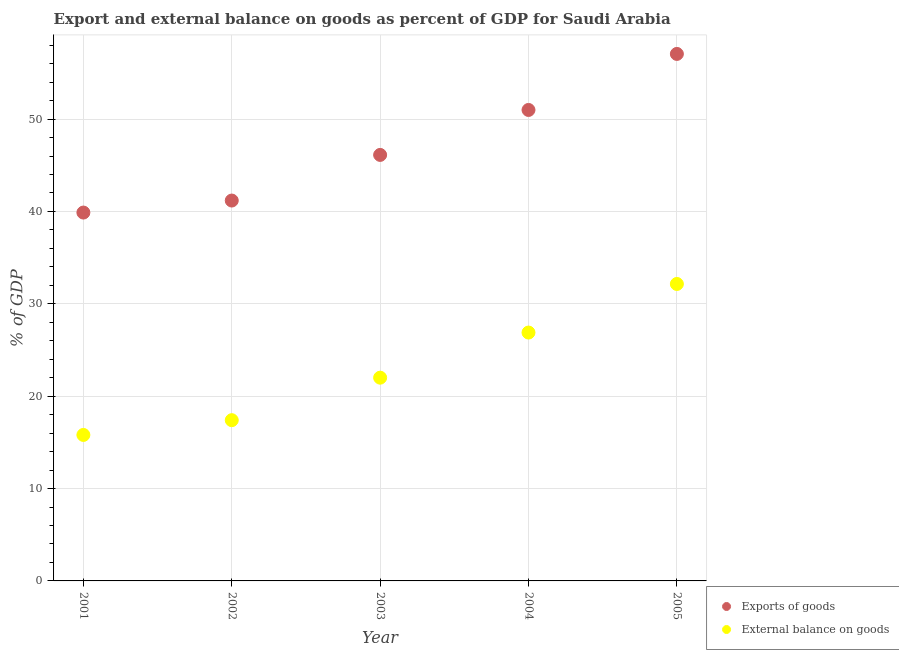How many different coloured dotlines are there?
Give a very brief answer. 2. What is the external balance on goods as percentage of gdp in 2005?
Provide a succinct answer. 32.15. Across all years, what is the maximum external balance on goods as percentage of gdp?
Keep it short and to the point. 32.15. Across all years, what is the minimum export of goods as percentage of gdp?
Provide a succinct answer. 39.88. In which year was the external balance on goods as percentage of gdp maximum?
Your answer should be compact. 2005. What is the total external balance on goods as percentage of gdp in the graph?
Your answer should be very brief. 114.24. What is the difference between the export of goods as percentage of gdp in 2003 and that in 2004?
Offer a terse response. -4.87. What is the difference between the export of goods as percentage of gdp in 2001 and the external balance on goods as percentage of gdp in 2002?
Your answer should be compact. 22.48. What is the average export of goods as percentage of gdp per year?
Make the answer very short. 47.04. In the year 2002, what is the difference between the export of goods as percentage of gdp and external balance on goods as percentage of gdp?
Your answer should be very brief. 23.78. What is the ratio of the export of goods as percentage of gdp in 2001 to that in 2003?
Give a very brief answer. 0.86. Is the external balance on goods as percentage of gdp in 2002 less than that in 2003?
Give a very brief answer. Yes. What is the difference between the highest and the second highest export of goods as percentage of gdp?
Your answer should be compact. 6.07. What is the difference between the highest and the lowest export of goods as percentage of gdp?
Ensure brevity in your answer.  17.17. How many dotlines are there?
Provide a succinct answer. 2. How many years are there in the graph?
Your answer should be compact. 5. What is the difference between two consecutive major ticks on the Y-axis?
Make the answer very short. 10. Are the values on the major ticks of Y-axis written in scientific E-notation?
Offer a terse response. No. Does the graph contain grids?
Offer a very short reply. Yes. Where does the legend appear in the graph?
Your answer should be very brief. Bottom right. How many legend labels are there?
Make the answer very short. 2. What is the title of the graph?
Your answer should be very brief. Export and external balance on goods as percent of GDP for Saudi Arabia. Does "Investment in Transport" appear as one of the legend labels in the graph?
Ensure brevity in your answer.  No. What is the label or title of the X-axis?
Give a very brief answer. Year. What is the label or title of the Y-axis?
Ensure brevity in your answer.  % of GDP. What is the % of GDP of Exports of goods in 2001?
Provide a succinct answer. 39.88. What is the % of GDP of External balance on goods in 2001?
Provide a short and direct response. 15.8. What is the % of GDP in Exports of goods in 2002?
Provide a short and direct response. 41.18. What is the % of GDP in External balance on goods in 2002?
Provide a succinct answer. 17.4. What is the % of GDP in Exports of goods in 2003?
Make the answer very short. 46.12. What is the % of GDP of External balance on goods in 2003?
Offer a terse response. 22. What is the % of GDP in Exports of goods in 2004?
Your answer should be compact. 50.99. What is the % of GDP in External balance on goods in 2004?
Keep it short and to the point. 26.89. What is the % of GDP of Exports of goods in 2005?
Ensure brevity in your answer.  57.05. What is the % of GDP of External balance on goods in 2005?
Your response must be concise. 32.15. Across all years, what is the maximum % of GDP of Exports of goods?
Offer a very short reply. 57.05. Across all years, what is the maximum % of GDP in External balance on goods?
Make the answer very short. 32.15. Across all years, what is the minimum % of GDP in Exports of goods?
Offer a terse response. 39.88. Across all years, what is the minimum % of GDP in External balance on goods?
Make the answer very short. 15.8. What is the total % of GDP in Exports of goods in the graph?
Offer a very short reply. 235.21. What is the total % of GDP of External balance on goods in the graph?
Offer a terse response. 114.24. What is the difference between the % of GDP of Exports of goods in 2001 and that in 2002?
Give a very brief answer. -1.3. What is the difference between the % of GDP in External balance on goods in 2001 and that in 2002?
Ensure brevity in your answer.  -1.6. What is the difference between the % of GDP of Exports of goods in 2001 and that in 2003?
Offer a very short reply. -6.24. What is the difference between the % of GDP of External balance on goods in 2001 and that in 2003?
Your answer should be very brief. -6.2. What is the difference between the % of GDP of Exports of goods in 2001 and that in 2004?
Give a very brief answer. -11.11. What is the difference between the % of GDP in External balance on goods in 2001 and that in 2004?
Give a very brief answer. -11.08. What is the difference between the % of GDP of Exports of goods in 2001 and that in 2005?
Ensure brevity in your answer.  -17.17. What is the difference between the % of GDP of External balance on goods in 2001 and that in 2005?
Give a very brief answer. -16.34. What is the difference between the % of GDP in Exports of goods in 2002 and that in 2003?
Provide a short and direct response. -4.94. What is the difference between the % of GDP of External balance on goods in 2002 and that in 2003?
Provide a succinct answer. -4.6. What is the difference between the % of GDP in Exports of goods in 2002 and that in 2004?
Give a very brief answer. -9.81. What is the difference between the % of GDP in External balance on goods in 2002 and that in 2004?
Ensure brevity in your answer.  -9.49. What is the difference between the % of GDP of Exports of goods in 2002 and that in 2005?
Provide a succinct answer. -15.87. What is the difference between the % of GDP of External balance on goods in 2002 and that in 2005?
Your answer should be compact. -14.75. What is the difference between the % of GDP of Exports of goods in 2003 and that in 2004?
Keep it short and to the point. -4.87. What is the difference between the % of GDP in External balance on goods in 2003 and that in 2004?
Give a very brief answer. -4.88. What is the difference between the % of GDP of Exports of goods in 2003 and that in 2005?
Provide a short and direct response. -10.93. What is the difference between the % of GDP of External balance on goods in 2003 and that in 2005?
Offer a very short reply. -10.14. What is the difference between the % of GDP of Exports of goods in 2004 and that in 2005?
Ensure brevity in your answer.  -6.07. What is the difference between the % of GDP of External balance on goods in 2004 and that in 2005?
Your answer should be very brief. -5.26. What is the difference between the % of GDP of Exports of goods in 2001 and the % of GDP of External balance on goods in 2002?
Provide a succinct answer. 22.48. What is the difference between the % of GDP of Exports of goods in 2001 and the % of GDP of External balance on goods in 2003?
Your response must be concise. 17.87. What is the difference between the % of GDP in Exports of goods in 2001 and the % of GDP in External balance on goods in 2004?
Your answer should be very brief. 12.99. What is the difference between the % of GDP in Exports of goods in 2001 and the % of GDP in External balance on goods in 2005?
Keep it short and to the point. 7.73. What is the difference between the % of GDP in Exports of goods in 2002 and the % of GDP in External balance on goods in 2003?
Your answer should be compact. 19.17. What is the difference between the % of GDP in Exports of goods in 2002 and the % of GDP in External balance on goods in 2004?
Your response must be concise. 14.29. What is the difference between the % of GDP of Exports of goods in 2002 and the % of GDP of External balance on goods in 2005?
Give a very brief answer. 9.03. What is the difference between the % of GDP of Exports of goods in 2003 and the % of GDP of External balance on goods in 2004?
Provide a succinct answer. 19.23. What is the difference between the % of GDP of Exports of goods in 2003 and the % of GDP of External balance on goods in 2005?
Make the answer very short. 13.97. What is the difference between the % of GDP in Exports of goods in 2004 and the % of GDP in External balance on goods in 2005?
Provide a short and direct response. 18.84. What is the average % of GDP in Exports of goods per year?
Make the answer very short. 47.04. What is the average % of GDP in External balance on goods per year?
Keep it short and to the point. 22.85. In the year 2001, what is the difference between the % of GDP of Exports of goods and % of GDP of External balance on goods?
Ensure brevity in your answer.  24.07. In the year 2002, what is the difference between the % of GDP of Exports of goods and % of GDP of External balance on goods?
Provide a succinct answer. 23.78. In the year 2003, what is the difference between the % of GDP of Exports of goods and % of GDP of External balance on goods?
Offer a very short reply. 24.11. In the year 2004, what is the difference between the % of GDP of Exports of goods and % of GDP of External balance on goods?
Your answer should be compact. 24.1. In the year 2005, what is the difference between the % of GDP in Exports of goods and % of GDP in External balance on goods?
Make the answer very short. 24.9. What is the ratio of the % of GDP in Exports of goods in 2001 to that in 2002?
Your answer should be very brief. 0.97. What is the ratio of the % of GDP in External balance on goods in 2001 to that in 2002?
Your answer should be compact. 0.91. What is the ratio of the % of GDP in Exports of goods in 2001 to that in 2003?
Give a very brief answer. 0.86. What is the ratio of the % of GDP in External balance on goods in 2001 to that in 2003?
Make the answer very short. 0.72. What is the ratio of the % of GDP in Exports of goods in 2001 to that in 2004?
Your response must be concise. 0.78. What is the ratio of the % of GDP of External balance on goods in 2001 to that in 2004?
Your answer should be compact. 0.59. What is the ratio of the % of GDP in Exports of goods in 2001 to that in 2005?
Make the answer very short. 0.7. What is the ratio of the % of GDP in External balance on goods in 2001 to that in 2005?
Provide a succinct answer. 0.49. What is the ratio of the % of GDP of Exports of goods in 2002 to that in 2003?
Your answer should be very brief. 0.89. What is the ratio of the % of GDP in External balance on goods in 2002 to that in 2003?
Ensure brevity in your answer.  0.79. What is the ratio of the % of GDP of Exports of goods in 2002 to that in 2004?
Make the answer very short. 0.81. What is the ratio of the % of GDP of External balance on goods in 2002 to that in 2004?
Give a very brief answer. 0.65. What is the ratio of the % of GDP in Exports of goods in 2002 to that in 2005?
Keep it short and to the point. 0.72. What is the ratio of the % of GDP in External balance on goods in 2002 to that in 2005?
Offer a terse response. 0.54. What is the ratio of the % of GDP of Exports of goods in 2003 to that in 2004?
Provide a succinct answer. 0.9. What is the ratio of the % of GDP in External balance on goods in 2003 to that in 2004?
Give a very brief answer. 0.82. What is the ratio of the % of GDP of Exports of goods in 2003 to that in 2005?
Make the answer very short. 0.81. What is the ratio of the % of GDP of External balance on goods in 2003 to that in 2005?
Provide a succinct answer. 0.68. What is the ratio of the % of GDP of Exports of goods in 2004 to that in 2005?
Ensure brevity in your answer.  0.89. What is the ratio of the % of GDP of External balance on goods in 2004 to that in 2005?
Your response must be concise. 0.84. What is the difference between the highest and the second highest % of GDP in Exports of goods?
Ensure brevity in your answer.  6.07. What is the difference between the highest and the second highest % of GDP in External balance on goods?
Provide a succinct answer. 5.26. What is the difference between the highest and the lowest % of GDP in Exports of goods?
Offer a terse response. 17.17. What is the difference between the highest and the lowest % of GDP of External balance on goods?
Your response must be concise. 16.34. 